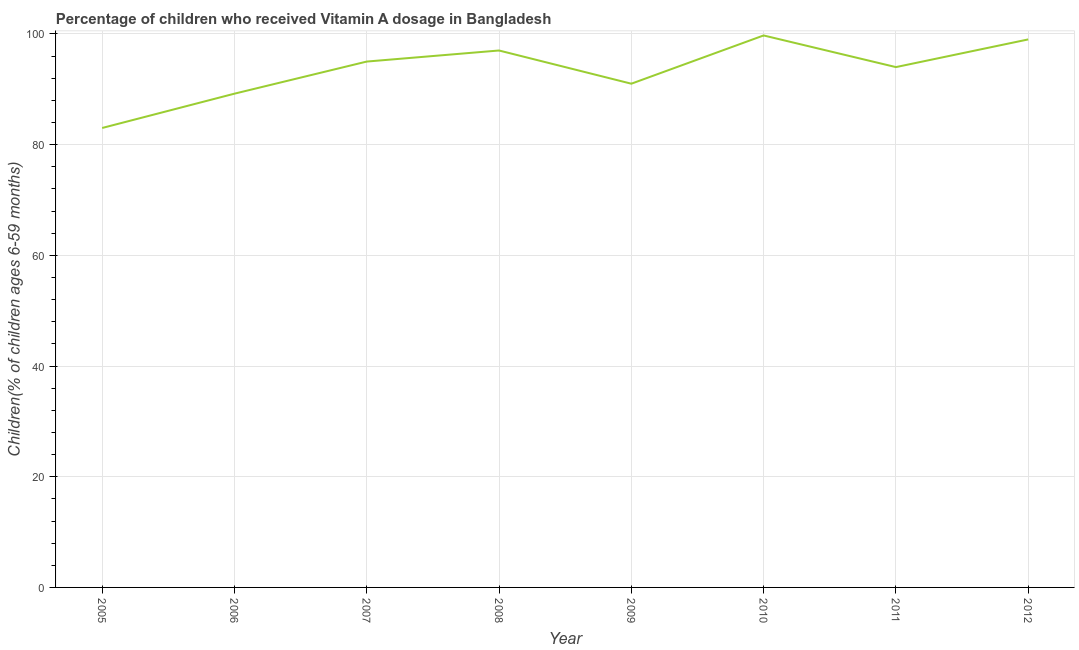What is the vitamin a supplementation coverage rate in 2008?
Provide a succinct answer. 97. Across all years, what is the maximum vitamin a supplementation coverage rate?
Ensure brevity in your answer.  99.72. Across all years, what is the minimum vitamin a supplementation coverage rate?
Your answer should be compact. 83. What is the sum of the vitamin a supplementation coverage rate?
Make the answer very short. 747.92. What is the difference between the vitamin a supplementation coverage rate in 2005 and 2009?
Ensure brevity in your answer.  -8. What is the average vitamin a supplementation coverage rate per year?
Offer a very short reply. 93.49. What is the median vitamin a supplementation coverage rate?
Give a very brief answer. 94.5. What is the ratio of the vitamin a supplementation coverage rate in 2006 to that in 2008?
Provide a succinct answer. 0.92. Is the vitamin a supplementation coverage rate in 2006 less than that in 2010?
Your answer should be compact. Yes. Is the difference between the vitamin a supplementation coverage rate in 2008 and 2009 greater than the difference between any two years?
Your answer should be compact. No. What is the difference between the highest and the second highest vitamin a supplementation coverage rate?
Offer a terse response. 0.72. Is the sum of the vitamin a supplementation coverage rate in 2007 and 2011 greater than the maximum vitamin a supplementation coverage rate across all years?
Offer a very short reply. Yes. What is the difference between the highest and the lowest vitamin a supplementation coverage rate?
Keep it short and to the point. 16.72. In how many years, is the vitamin a supplementation coverage rate greater than the average vitamin a supplementation coverage rate taken over all years?
Provide a succinct answer. 5. How many lines are there?
Give a very brief answer. 1. Are the values on the major ticks of Y-axis written in scientific E-notation?
Your answer should be compact. No. Does the graph contain any zero values?
Your answer should be very brief. No. What is the title of the graph?
Keep it short and to the point. Percentage of children who received Vitamin A dosage in Bangladesh. What is the label or title of the X-axis?
Make the answer very short. Year. What is the label or title of the Y-axis?
Provide a succinct answer. Children(% of children ages 6-59 months). What is the Children(% of children ages 6-59 months) in 2006?
Offer a very short reply. 89.2. What is the Children(% of children ages 6-59 months) in 2007?
Provide a succinct answer. 95. What is the Children(% of children ages 6-59 months) of 2008?
Offer a terse response. 97. What is the Children(% of children ages 6-59 months) in 2009?
Your answer should be very brief. 91. What is the Children(% of children ages 6-59 months) in 2010?
Give a very brief answer. 99.72. What is the Children(% of children ages 6-59 months) in 2011?
Offer a very short reply. 94. What is the Children(% of children ages 6-59 months) of 2012?
Your response must be concise. 99. What is the difference between the Children(% of children ages 6-59 months) in 2005 and 2006?
Keep it short and to the point. -6.2. What is the difference between the Children(% of children ages 6-59 months) in 2005 and 2007?
Give a very brief answer. -12. What is the difference between the Children(% of children ages 6-59 months) in 2005 and 2010?
Your response must be concise. -16.72. What is the difference between the Children(% of children ages 6-59 months) in 2005 and 2011?
Your answer should be compact. -11. What is the difference between the Children(% of children ages 6-59 months) in 2005 and 2012?
Your answer should be very brief. -16. What is the difference between the Children(% of children ages 6-59 months) in 2006 and 2010?
Your answer should be compact. -10.52. What is the difference between the Children(% of children ages 6-59 months) in 2006 and 2011?
Your answer should be compact. -4.8. What is the difference between the Children(% of children ages 6-59 months) in 2006 and 2012?
Offer a very short reply. -9.8. What is the difference between the Children(% of children ages 6-59 months) in 2007 and 2008?
Your answer should be compact. -2. What is the difference between the Children(% of children ages 6-59 months) in 2007 and 2010?
Give a very brief answer. -4.72. What is the difference between the Children(% of children ages 6-59 months) in 2008 and 2009?
Your answer should be very brief. 6. What is the difference between the Children(% of children ages 6-59 months) in 2008 and 2010?
Give a very brief answer. -2.72. What is the difference between the Children(% of children ages 6-59 months) in 2009 and 2010?
Your response must be concise. -8.72. What is the difference between the Children(% of children ages 6-59 months) in 2010 and 2011?
Your response must be concise. 5.72. What is the difference between the Children(% of children ages 6-59 months) in 2010 and 2012?
Make the answer very short. 0.72. What is the ratio of the Children(% of children ages 6-59 months) in 2005 to that in 2007?
Your response must be concise. 0.87. What is the ratio of the Children(% of children ages 6-59 months) in 2005 to that in 2008?
Offer a terse response. 0.86. What is the ratio of the Children(% of children ages 6-59 months) in 2005 to that in 2009?
Ensure brevity in your answer.  0.91. What is the ratio of the Children(% of children ages 6-59 months) in 2005 to that in 2010?
Your answer should be very brief. 0.83. What is the ratio of the Children(% of children ages 6-59 months) in 2005 to that in 2011?
Provide a succinct answer. 0.88. What is the ratio of the Children(% of children ages 6-59 months) in 2005 to that in 2012?
Offer a very short reply. 0.84. What is the ratio of the Children(% of children ages 6-59 months) in 2006 to that in 2007?
Keep it short and to the point. 0.94. What is the ratio of the Children(% of children ages 6-59 months) in 2006 to that in 2008?
Provide a succinct answer. 0.92. What is the ratio of the Children(% of children ages 6-59 months) in 2006 to that in 2010?
Provide a succinct answer. 0.9. What is the ratio of the Children(% of children ages 6-59 months) in 2006 to that in 2011?
Offer a terse response. 0.95. What is the ratio of the Children(% of children ages 6-59 months) in 2006 to that in 2012?
Your answer should be compact. 0.9. What is the ratio of the Children(% of children ages 6-59 months) in 2007 to that in 2008?
Your answer should be compact. 0.98. What is the ratio of the Children(% of children ages 6-59 months) in 2007 to that in 2009?
Offer a terse response. 1.04. What is the ratio of the Children(% of children ages 6-59 months) in 2007 to that in 2010?
Ensure brevity in your answer.  0.95. What is the ratio of the Children(% of children ages 6-59 months) in 2007 to that in 2011?
Provide a short and direct response. 1.01. What is the ratio of the Children(% of children ages 6-59 months) in 2008 to that in 2009?
Your answer should be compact. 1.07. What is the ratio of the Children(% of children ages 6-59 months) in 2008 to that in 2010?
Offer a very short reply. 0.97. What is the ratio of the Children(% of children ages 6-59 months) in 2008 to that in 2011?
Provide a short and direct response. 1.03. What is the ratio of the Children(% of children ages 6-59 months) in 2008 to that in 2012?
Offer a very short reply. 0.98. What is the ratio of the Children(% of children ages 6-59 months) in 2009 to that in 2010?
Give a very brief answer. 0.91. What is the ratio of the Children(% of children ages 6-59 months) in 2009 to that in 2012?
Give a very brief answer. 0.92. What is the ratio of the Children(% of children ages 6-59 months) in 2010 to that in 2011?
Your response must be concise. 1.06. What is the ratio of the Children(% of children ages 6-59 months) in 2011 to that in 2012?
Offer a very short reply. 0.95. 